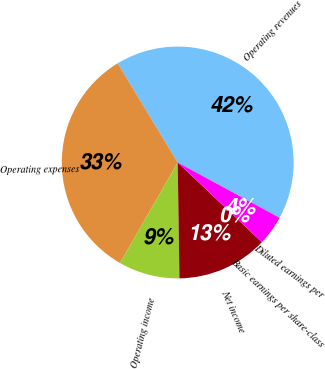Convert chart. <chart><loc_0><loc_0><loc_500><loc_500><pie_chart><fcel>Operating revenues<fcel>Operating expenses<fcel>Operating income<fcel>Net income<fcel>Basic earnings per share-class<fcel>Diluted earnings per<nl><fcel>41.57%<fcel>33.04%<fcel>8.53%<fcel>12.69%<fcel>0.0%<fcel>4.16%<nl></chart> 